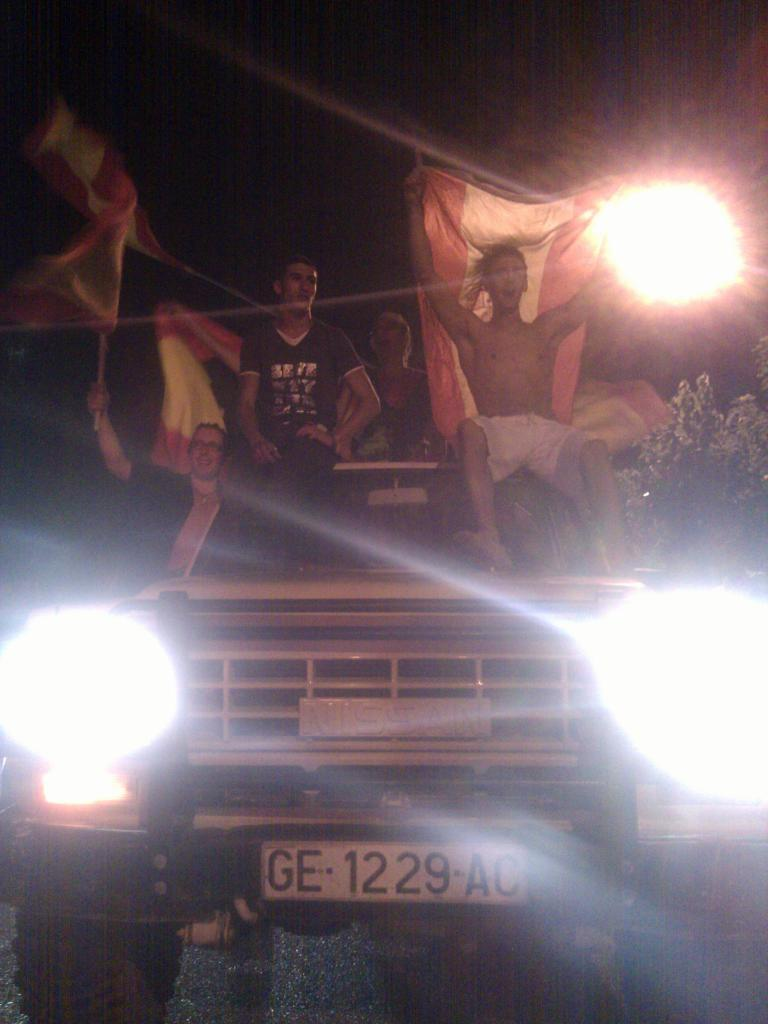How many people are in the image? There are three people in the image. What are the people doing in the image? The three people are sitting on a jeep. What are the people holding in their hands? The three people are holding a flag in their hands. What type of screw can be seen on the jeep in the image? There is no screw visible on the jeep in the image. Can you see any ladybugs on the flag in the image? There are no ladybugs present in the image. 